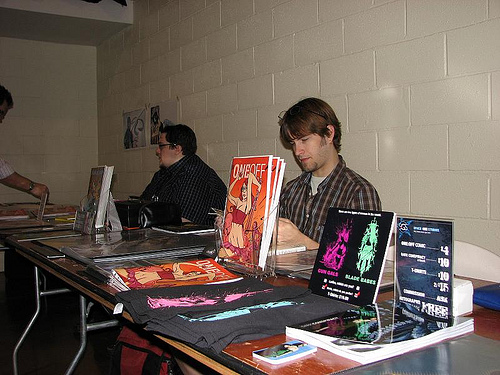<image>
Is the man behind the table? Yes. From this viewpoint, the man is positioned behind the table, with the table partially or fully occluding the man. Is there a man behind the book? Yes. From this viewpoint, the man is positioned behind the book, with the book partially or fully occluding the man. 